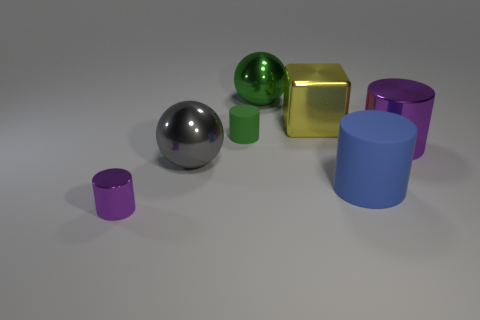Can you describe the texture of the objects shown? Certainly! The objects appear to have a smooth, reflective texture indicative of a metallic or polished surface. This attribute allows the objects to reflect light and cast shadows, giving a sense of depth and realism to the scene. 